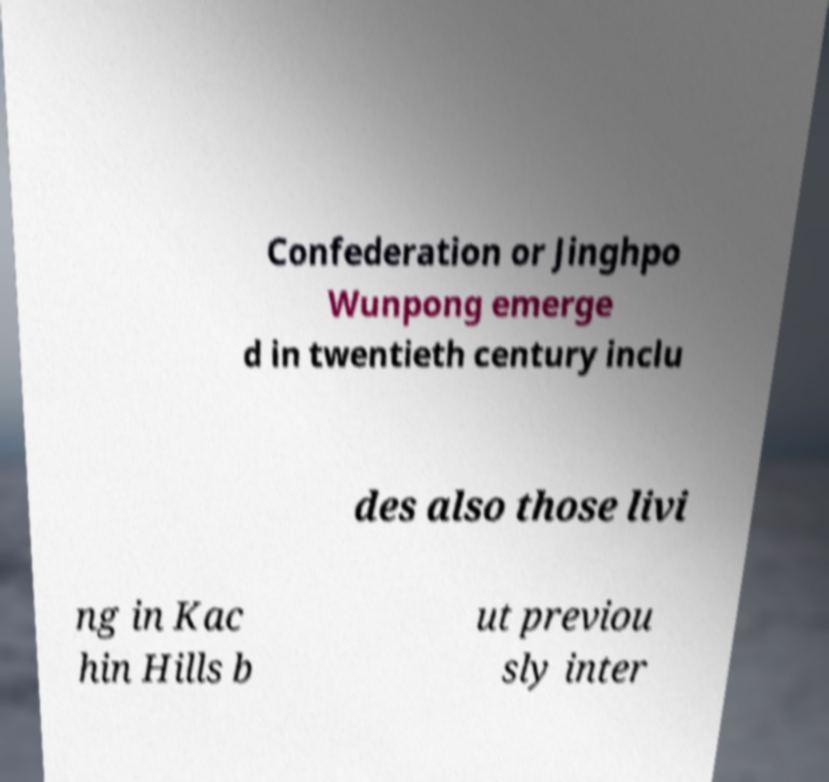Could you extract and type out the text from this image? Confederation or Jinghpo Wunpong emerge d in twentieth century inclu des also those livi ng in Kac hin Hills b ut previou sly inter 